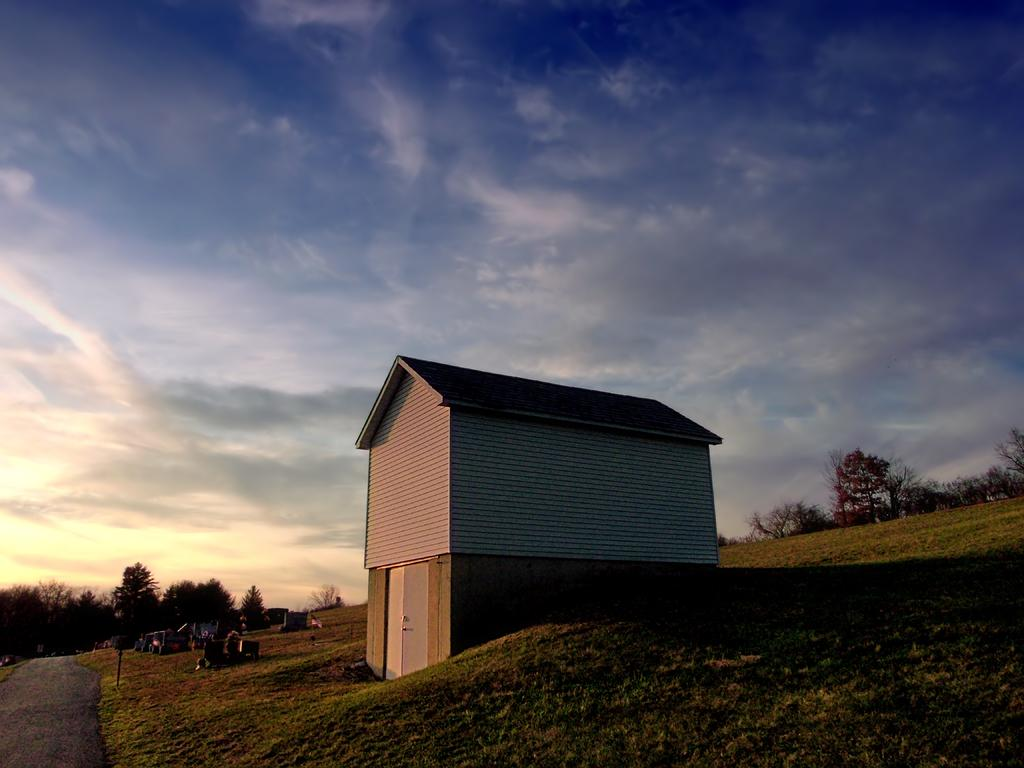What colors are used to paint the building in the image? The building in the image is white and gray. What can be seen in the background of the image? There are trees in the background of the image. What is the color of the sky in the image? The sky is blue and white in the image. What type of industry is depicted in the image? There is no industry depicted in the image; it features a building, trees, and a blue and white sky. What type of pleasure can be seen in the image? There is no specific pleasure depicted in the image; it is a scene of a building, trees, and a sky. 